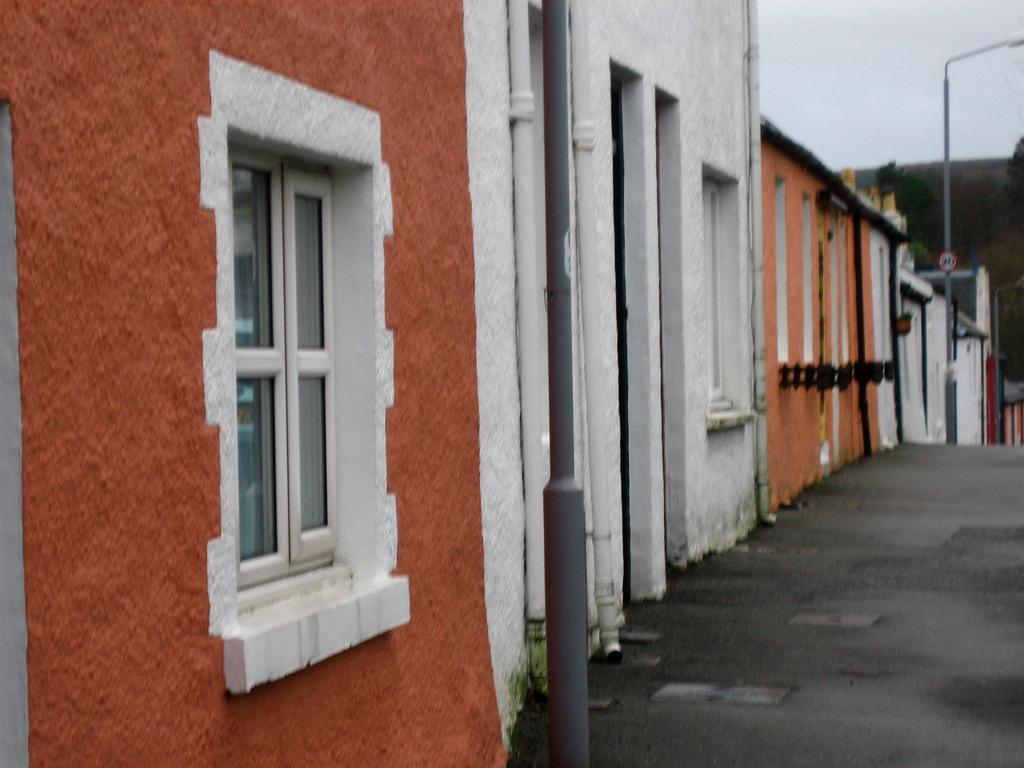Describe this image in one or two sentences. In this image there are houses, poles, sign board , road, trees, and in the background there is sky. 